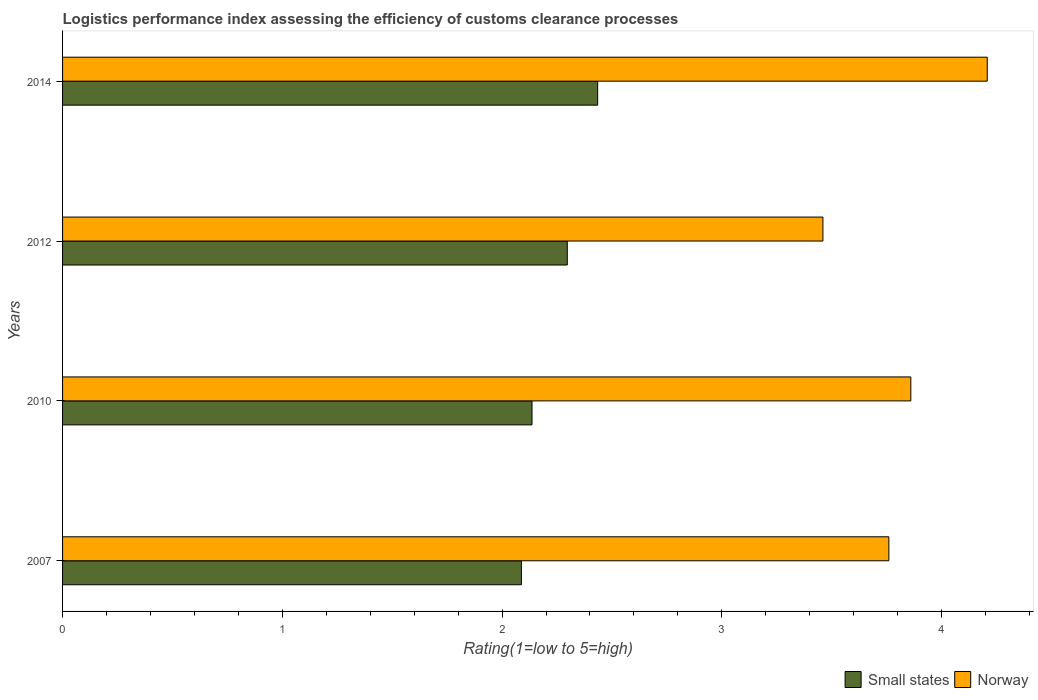Are the number of bars per tick equal to the number of legend labels?
Keep it short and to the point. Yes. How many bars are there on the 4th tick from the top?
Ensure brevity in your answer.  2. How many bars are there on the 2nd tick from the bottom?
Keep it short and to the point. 2. What is the label of the 3rd group of bars from the top?
Your response must be concise. 2010. What is the Logistic performance index in Small states in 2014?
Your answer should be very brief. 2.43. Across all years, what is the maximum Logistic performance index in Norway?
Your response must be concise. 4.21. Across all years, what is the minimum Logistic performance index in Norway?
Your response must be concise. 3.46. In which year was the Logistic performance index in Norway maximum?
Keep it short and to the point. 2014. In which year was the Logistic performance index in Small states minimum?
Your answer should be very brief. 2007. What is the total Logistic performance index in Norway in the graph?
Your answer should be very brief. 15.29. What is the difference between the Logistic performance index in Norway in 2012 and that in 2014?
Make the answer very short. -0.75. What is the difference between the Logistic performance index in Norway in 2014 and the Logistic performance index in Small states in 2007?
Your answer should be compact. 2.12. What is the average Logistic performance index in Small states per year?
Provide a short and direct response. 2.24. In the year 2007, what is the difference between the Logistic performance index in Norway and Logistic performance index in Small states?
Offer a very short reply. 1.67. In how many years, is the Logistic performance index in Small states greater than 3.8 ?
Make the answer very short. 0. What is the ratio of the Logistic performance index in Small states in 2010 to that in 2012?
Offer a very short reply. 0.93. Is the Logistic performance index in Small states in 2012 less than that in 2014?
Your answer should be very brief. Yes. Is the difference between the Logistic performance index in Norway in 2007 and 2012 greater than the difference between the Logistic performance index in Small states in 2007 and 2012?
Keep it short and to the point. Yes. What is the difference between the highest and the second highest Logistic performance index in Norway?
Offer a terse response. 0.35. What is the difference between the highest and the lowest Logistic performance index in Norway?
Offer a terse response. 0.75. In how many years, is the Logistic performance index in Small states greater than the average Logistic performance index in Small states taken over all years?
Your answer should be compact. 2. What does the 2nd bar from the top in 2012 represents?
Provide a short and direct response. Small states. Are the values on the major ticks of X-axis written in scientific E-notation?
Give a very brief answer. No. How are the legend labels stacked?
Make the answer very short. Horizontal. What is the title of the graph?
Offer a very short reply. Logistics performance index assessing the efficiency of customs clearance processes. Does "Gambia, The" appear as one of the legend labels in the graph?
Provide a short and direct response. No. What is the label or title of the X-axis?
Provide a short and direct response. Rating(1=low to 5=high). What is the Rating(1=low to 5=high) in Small states in 2007?
Give a very brief answer. 2.09. What is the Rating(1=low to 5=high) of Norway in 2007?
Your answer should be very brief. 3.76. What is the Rating(1=low to 5=high) of Small states in 2010?
Make the answer very short. 2.14. What is the Rating(1=low to 5=high) in Norway in 2010?
Your answer should be very brief. 3.86. What is the Rating(1=low to 5=high) of Small states in 2012?
Your answer should be compact. 2.3. What is the Rating(1=low to 5=high) of Norway in 2012?
Your answer should be very brief. 3.46. What is the Rating(1=low to 5=high) of Small states in 2014?
Your answer should be compact. 2.43. What is the Rating(1=low to 5=high) of Norway in 2014?
Your response must be concise. 4.21. Across all years, what is the maximum Rating(1=low to 5=high) in Small states?
Your answer should be very brief. 2.43. Across all years, what is the maximum Rating(1=low to 5=high) of Norway?
Your answer should be very brief. 4.21. Across all years, what is the minimum Rating(1=low to 5=high) of Small states?
Offer a very short reply. 2.09. Across all years, what is the minimum Rating(1=low to 5=high) in Norway?
Your answer should be compact. 3.46. What is the total Rating(1=low to 5=high) in Small states in the graph?
Give a very brief answer. 8.96. What is the total Rating(1=low to 5=high) of Norway in the graph?
Offer a terse response. 15.29. What is the difference between the Rating(1=low to 5=high) of Small states in 2007 and that in 2010?
Give a very brief answer. -0.05. What is the difference between the Rating(1=low to 5=high) of Norway in 2007 and that in 2010?
Your answer should be very brief. -0.1. What is the difference between the Rating(1=low to 5=high) of Small states in 2007 and that in 2012?
Give a very brief answer. -0.21. What is the difference between the Rating(1=low to 5=high) of Small states in 2007 and that in 2014?
Give a very brief answer. -0.35. What is the difference between the Rating(1=low to 5=high) in Norway in 2007 and that in 2014?
Provide a succinct answer. -0.45. What is the difference between the Rating(1=low to 5=high) in Small states in 2010 and that in 2012?
Your response must be concise. -0.16. What is the difference between the Rating(1=low to 5=high) in Small states in 2010 and that in 2014?
Ensure brevity in your answer.  -0.3. What is the difference between the Rating(1=low to 5=high) of Norway in 2010 and that in 2014?
Provide a short and direct response. -0.35. What is the difference between the Rating(1=low to 5=high) of Small states in 2012 and that in 2014?
Your answer should be compact. -0.14. What is the difference between the Rating(1=low to 5=high) of Norway in 2012 and that in 2014?
Keep it short and to the point. -0.75. What is the difference between the Rating(1=low to 5=high) of Small states in 2007 and the Rating(1=low to 5=high) of Norway in 2010?
Ensure brevity in your answer.  -1.77. What is the difference between the Rating(1=low to 5=high) of Small states in 2007 and the Rating(1=low to 5=high) of Norway in 2012?
Provide a short and direct response. -1.37. What is the difference between the Rating(1=low to 5=high) of Small states in 2007 and the Rating(1=low to 5=high) of Norway in 2014?
Offer a very short reply. -2.12. What is the difference between the Rating(1=low to 5=high) of Small states in 2010 and the Rating(1=low to 5=high) of Norway in 2012?
Your response must be concise. -1.32. What is the difference between the Rating(1=low to 5=high) in Small states in 2010 and the Rating(1=low to 5=high) in Norway in 2014?
Provide a succinct answer. -2.07. What is the difference between the Rating(1=low to 5=high) in Small states in 2012 and the Rating(1=low to 5=high) in Norway in 2014?
Provide a short and direct response. -1.91. What is the average Rating(1=low to 5=high) of Small states per year?
Your answer should be very brief. 2.24. What is the average Rating(1=low to 5=high) in Norway per year?
Ensure brevity in your answer.  3.82. In the year 2007, what is the difference between the Rating(1=low to 5=high) of Small states and Rating(1=low to 5=high) of Norway?
Your answer should be very brief. -1.67. In the year 2010, what is the difference between the Rating(1=low to 5=high) of Small states and Rating(1=low to 5=high) of Norway?
Provide a succinct answer. -1.72. In the year 2012, what is the difference between the Rating(1=low to 5=high) of Small states and Rating(1=low to 5=high) of Norway?
Your answer should be very brief. -1.16. In the year 2014, what is the difference between the Rating(1=low to 5=high) in Small states and Rating(1=low to 5=high) in Norway?
Provide a succinct answer. -1.77. What is the ratio of the Rating(1=low to 5=high) in Small states in 2007 to that in 2010?
Make the answer very short. 0.98. What is the ratio of the Rating(1=low to 5=high) of Norway in 2007 to that in 2010?
Provide a succinct answer. 0.97. What is the ratio of the Rating(1=low to 5=high) in Small states in 2007 to that in 2012?
Keep it short and to the point. 0.91. What is the ratio of the Rating(1=low to 5=high) in Norway in 2007 to that in 2012?
Give a very brief answer. 1.09. What is the ratio of the Rating(1=low to 5=high) of Small states in 2007 to that in 2014?
Give a very brief answer. 0.86. What is the ratio of the Rating(1=low to 5=high) in Norway in 2007 to that in 2014?
Your answer should be compact. 0.89. What is the ratio of the Rating(1=low to 5=high) of Small states in 2010 to that in 2012?
Offer a very short reply. 0.93. What is the ratio of the Rating(1=low to 5=high) in Norway in 2010 to that in 2012?
Ensure brevity in your answer.  1.12. What is the ratio of the Rating(1=low to 5=high) of Small states in 2010 to that in 2014?
Provide a succinct answer. 0.88. What is the ratio of the Rating(1=low to 5=high) of Norway in 2010 to that in 2014?
Provide a short and direct response. 0.92. What is the ratio of the Rating(1=low to 5=high) in Small states in 2012 to that in 2014?
Offer a very short reply. 0.94. What is the ratio of the Rating(1=low to 5=high) of Norway in 2012 to that in 2014?
Make the answer very short. 0.82. What is the difference between the highest and the second highest Rating(1=low to 5=high) of Small states?
Provide a succinct answer. 0.14. What is the difference between the highest and the second highest Rating(1=low to 5=high) of Norway?
Offer a very short reply. 0.35. What is the difference between the highest and the lowest Rating(1=low to 5=high) of Small states?
Your answer should be very brief. 0.35. What is the difference between the highest and the lowest Rating(1=low to 5=high) in Norway?
Offer a terse response. 0.75. 